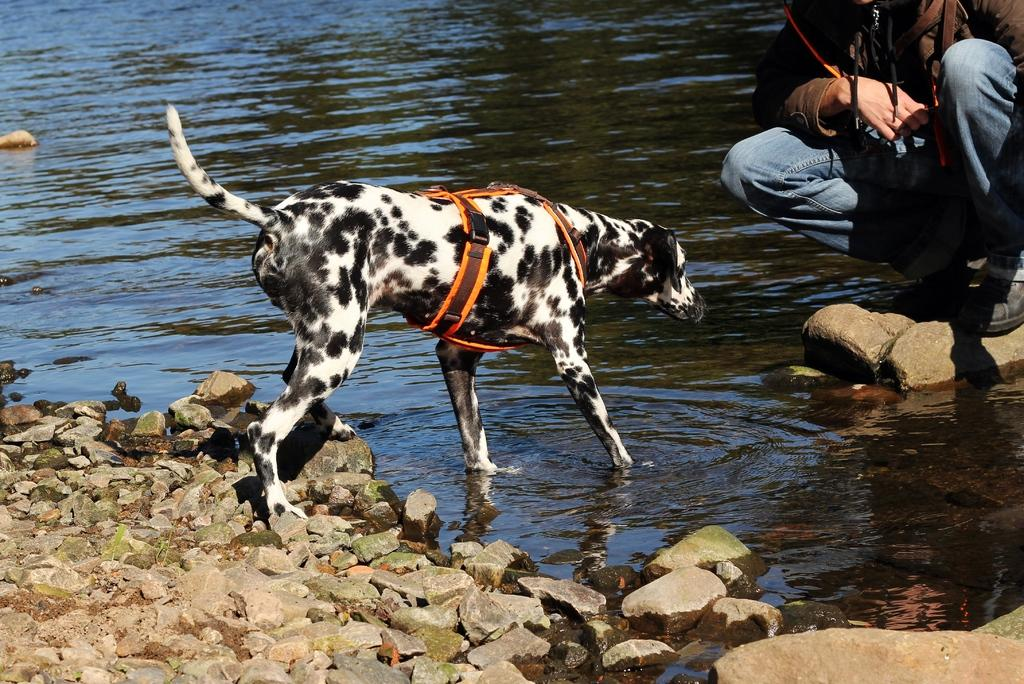What is the dog doing in the image? The dog is in the water. Can you describe the person in the image? The person is in the image, standing on a rock, wearing shoes and jeans. How many legs of the dog are on the rocks? The dog has two legs on rocks on the land. What type of hat is the person wearing in the image? There is no hat present in the image; the person is wearing jeans and shoes. Can you tell me where the person is going based on the map in the image? There is no map present in the image, so it is not possible to determine the person's destination. 